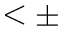<formula> <loc_0><loc_0><loc_500><loc_500>< \pm</formula> 